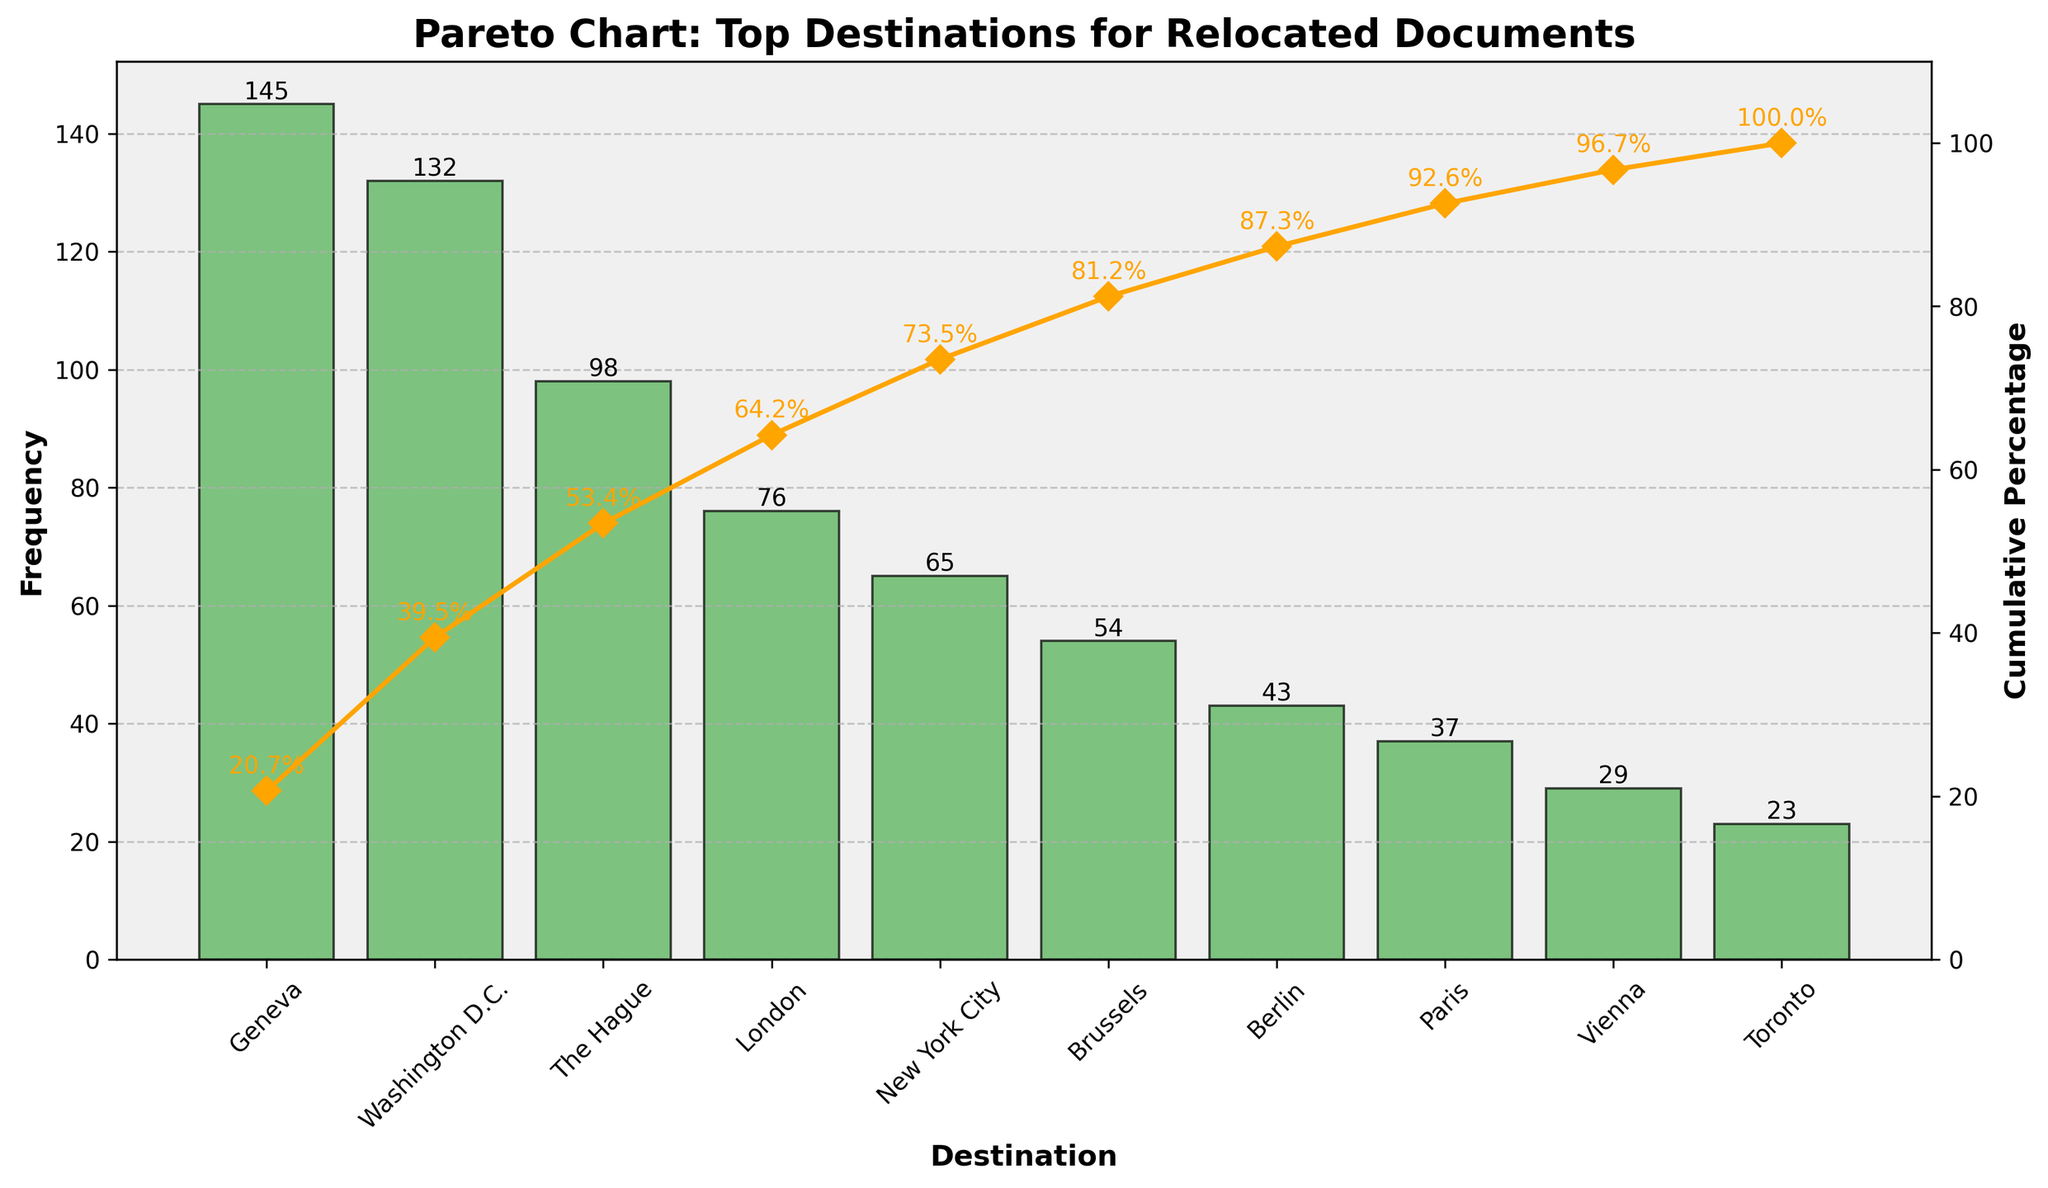What is the title of the chart? You can find the title at the top of the chart. It reads "Pareto Chart: Top Destinations for Relocated Documents".
Answer: Pareto Chart: Top Destinations for Relocated Documents How many destinations are listed in the chart? Count the number of bars or destinations shown along the x-axis. There are ten destinations listed.
Answer: 10 Which destination has the highest frequency of relocated documents? Look for the tallest bar in the chart. The bar representing Geneva is the tallest, indicating it has the highest frequency.
Answer: Geneva What is the cumulative percentage for Washington D.C.? Trace the point where the cumulative percentage line intersects with Washington D.C. on the x-axis and read the corresponding y-axis value on the right. It is 47.1%.
Answer: 47.1% How many documents were relocated to Paris? Find the bar aligned with "Paris" on the x-axis and read the value label at the top of the bar. It shows 37 documents.
Answer: 37 What is the combined frequency of documents relocated to Vienna and Toronto? Add the frequencies for Vienna (29) and Toronto (23). The combined frequency is 29 + 23 = 52.
Answer: 52 What percentage of total relocated documents is accounted for by Geneva alone? Divide the frequency of Geneva (145) by the total sum of frequencies (702) and multiply by 100. (145 / 702) * 100 ≈ 20.7%.
Answer: 20.7% Which destination ranks third in terms of document frequency? The third tallest bar indicates the destination. Following Geneva and Washington D.C., The Hague ranks third.
Answer: The Hague What is the difference in cumulative percentage between Brussels and Berlin? Read the cumulative percentage values for both: Brussels is 81.2% and Berlin is 87.3%. The difference is 87.3% - 81.2% = 6.1%.
Answer: 6.1% What cumulative percentage is reached by the top five destinations combined? Add the frequencies of the top five destinations: Geneva (145), Washington D.C. (132), The Hague (98), London (76), and New York City (65), then divide by the total frequency and multiply by 100. Sum is 145 + 132 + 98 + 76 + 65 = 516. (516 / 702) * 100 ≈ 73.5%.
Answer: 73.5% 